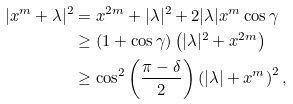Convert formula to latex. <formula><loc_0><loc_0><loc_500><loc_500>| x ^ { m } + \lambda | ^ { 2 } & = x ^ { 2 m } + | \lambda | ^ { 2 } + 2 | \lambda | x ^ { m } \cos \gamma \\ & \geq ( 1 + \cos \gamma ) \left ( | \lambda | ^ { 2 } + x ^ { 2 m } \right ) \\ & \geq \cos ^ { 2 } \left ( \frac { \pi - \delta } { 2 } \right ) \left ( | \lambda | + x ^ { m } \right ) ^ { 2 } ,</formula> 